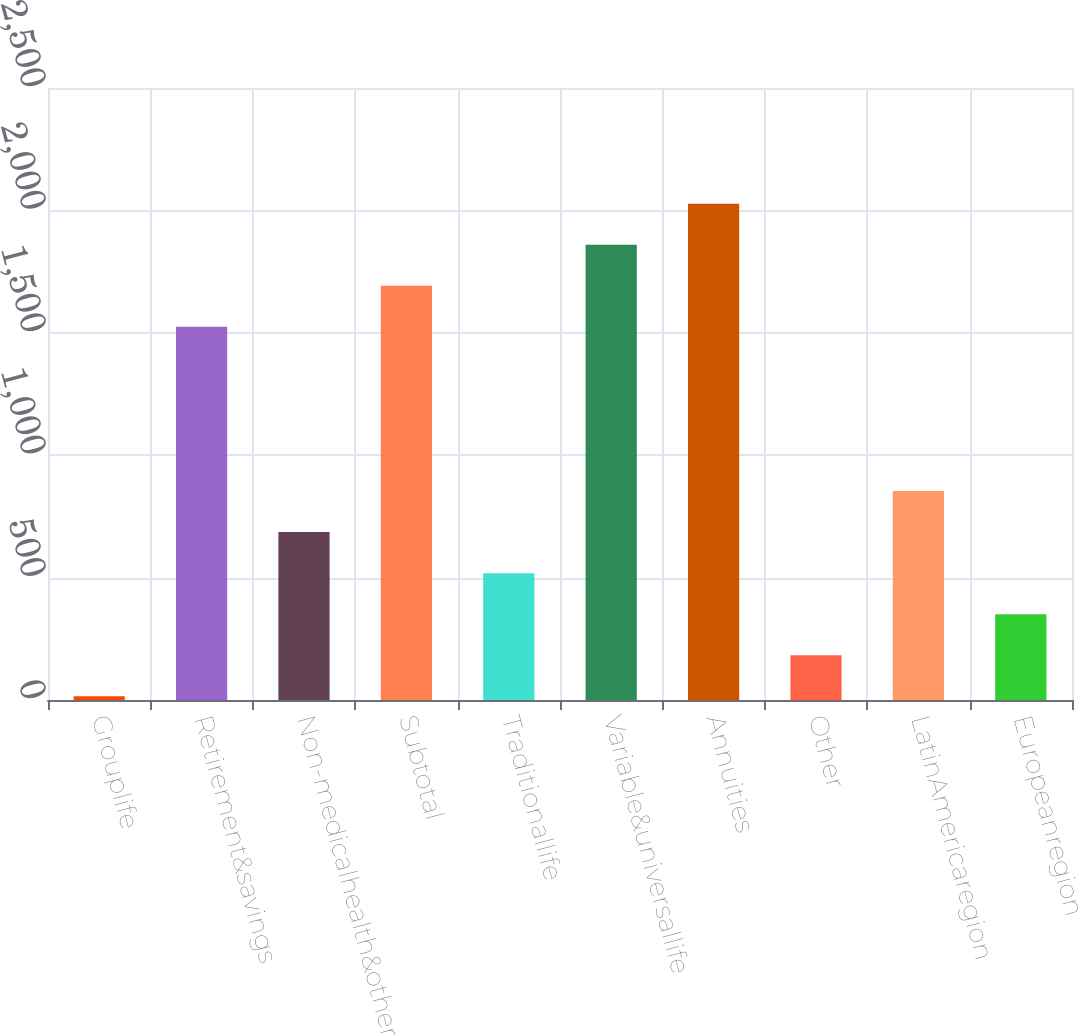Convert chart to OTSL. <chart><loc_0><loc_0><loc_500><loc_500><bar_chart><fcel>Grouplife<fcel>Retirement&savings<fcel>Non-medicalhealth&other<fcel>Subtotal<fcel>Traditionallife<fcel>Variable&universallife<fcel>Annuities<fcel>Other<fcel>LatinAmericaregion<fcel>Europeanregion<nl><fcel>15<fcel>1524.3<fcel>685.8<fcel>1692<fcel>518.1<fcel>1859.7<fcel>2027.4<fcel>182.7<fcel>853.5<fcel>350.4<nl></chart> 